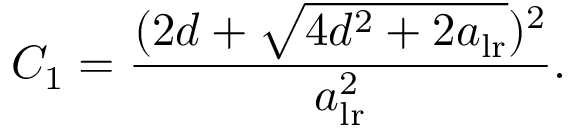Convert formula to latex. <formula><loc_0><loc_0><loc_500><loc_500>C _ { 1 } = \frac { ( 2 d + \sqrt { 4 d ^ { 2 } + 2 a _ { l r } } ) ^ { 2 } } { a _ { l r } ^ { 2 } } .</formula> 